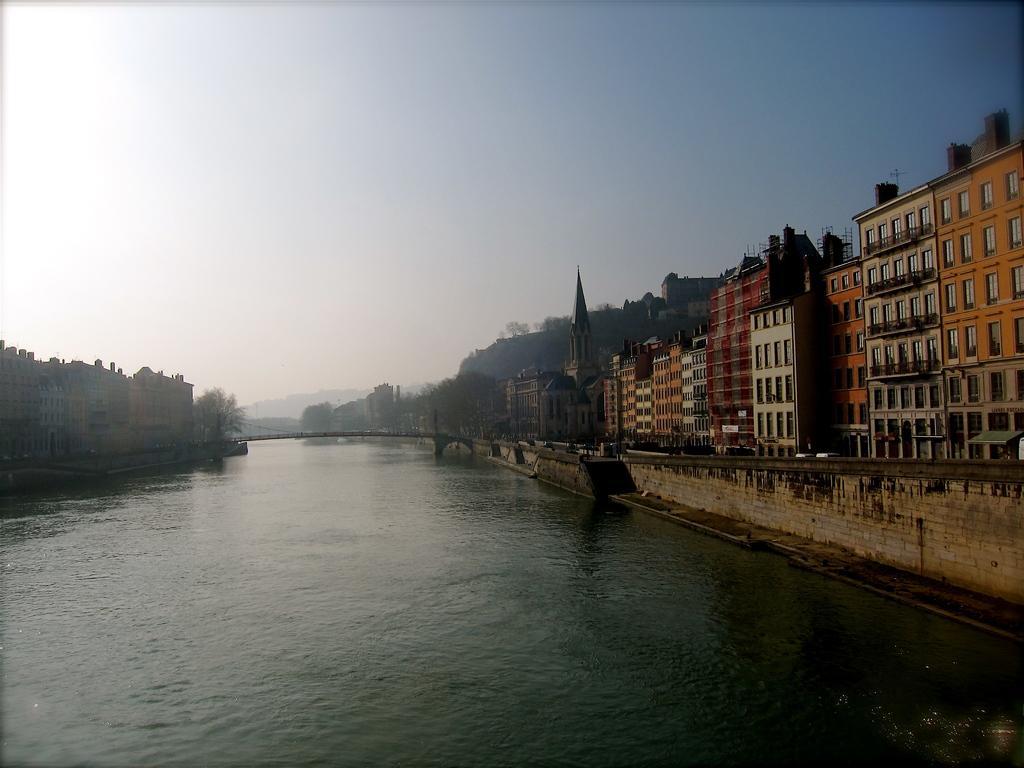Could you give a brief overview of what you see in this image? In the picture we can see the water on either sides of the water we can see path, trees, buildings with windows and glass to it and in the background we can see hills and sky. 